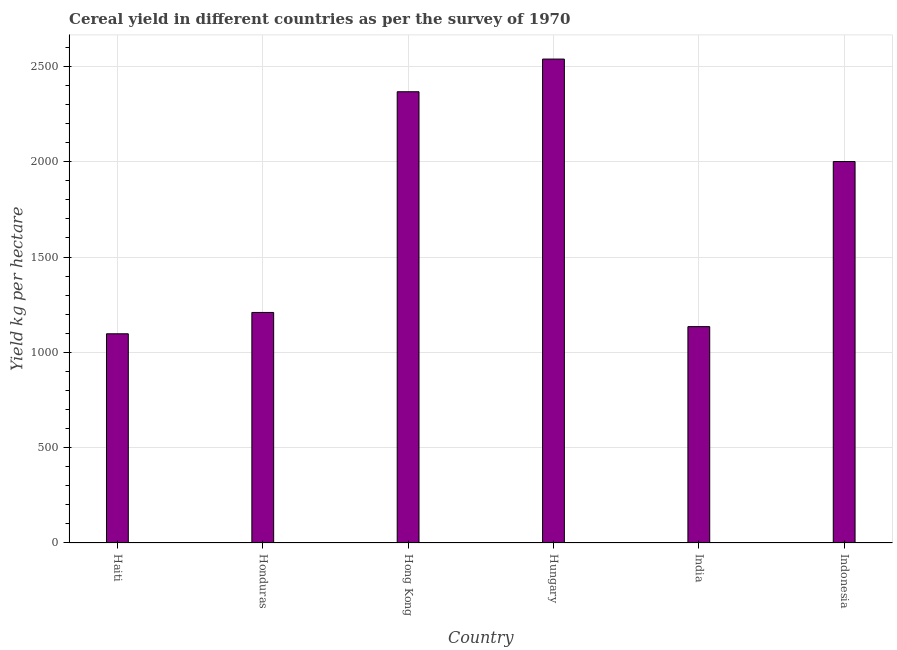Does the graph contain grids?
Give a very brief answer. Yes. What is the title of the graph?
Your response must be concise. Cereal yield in different countries as per the survey of 1970. What is the label or title of the Y-axis?
Keep it short and to the point. Yield kg per hectare. What is the cereal yield in Indonesia?
Your answer should be compact. 2000.8. Across all countries, what is the maximum cereal yield?
Give a very brief answer. 2538.25. Across all countries, what is the minimum cereal yield?
Provide a succinct answer. 1097.31. In which country was the cereal yield maximum?
Your answer should be compact. Hungary. In which country was the cereal yield minimum?
Your answer should be compact. Haiti. What is the sum of the cereal yield?
Provide a short and direct response. 1.03e+04. What is the difference between the cereal yield in Hungary and Indonesia?
Give a very brief answer. 537.45. What is the average cereal yield per country?
Ensure brevity in your answer.  1724.54. What is the median cereal yield?
Provide a short and direct response. 1605.01. In how many countries, is the cereal yield greater than 2400 kg per hectare?
Offer a very short reply. 1. What is the ratio of the cereal yield in Hong Kong to that in Hungary?
Keep it short and to the point. 0.93. Is the cereal yield in Haiti less than that in Honduras?
Provide a short and direct response. Yes. Is the difference between the cereal yield in Haiti and India greater than the difference between any two countries?
Your answer should be compact. No. What is the difference between the highest and the second highest cereal yield?
Give a very brief answer. 171.39. Is the sum of the cereal yield in Honduras and India greater than the maximum cereal yield across all countries?
Provide a succinct answer. No. What is the difference between the highest and the lowest cereal yield?
Ensure brevity in your answer.  1440.94. Are all the bars in the graph horizontal?
Offer a terse response. No. What is the difference between two consecutive major ticks on the Y-axis?
Your answer should be compact. 500. Are the values on the major ticks of Y-axis written in scientific E-notation?
Your answer should be very brief. No. What is the Yield kg per hectare in Haiti?
Your response must be concise. 1097.31. What is the Yield kg per hectare in Honduras?
Provide a succinct answer. 1209.22. What is the Yield kg per hectare of Hong Kong?
Give a very brief answer. 2366.86. What is the Yield kg per hectare in Hungary?
Your response must be concise. 2538.25. What is the Yield kg per hectare in India?
Give a very brief answer. 1134.82. What is the Yield kg per hectare of Indonesia?
Give a very brief answer. 2000.8. What is the difference between the Yield kg per hectare in Haiti and Honduras?
Give a very brief answer. -111.91. What is the difference between the Yield kg per hectare in Haiti and Hong Kong?
Your answer should be very brief. -1269.55. What is the difference between the Yield kg per hectare in Haiti and Hungary?
Give a very brief answer. -1440.94. What is the difference between the Yield kg per hectare in Haiti and India?
Give a very brief answer. -37.51. What is the difference between the Yield kg per hectare in Haiti and Indonesia?
Make the answer very short. -903.49. What is the difference between the Yield kg per hectare in Honduras and Hong Kong?
Your response must be concise. -1157.64. What is the difference between the Yield kg per hectare in Honduras and Hungary?
Your answer should be compact. -1329.03. What is the difference between the Yield kg per hectare in Honduras and India?
Keep it short and to the point. 74.4. What is the difference between the Yield kg per hectare in Honduras and Indonesia?
Ensure brevity in your answer.  -791.58. What is the difference between the Yield kg per hectare in Hong Kong and Hungary?
Your answer should be compact. -171.39. What is the difference between the Yield kg per hectare in Hong Kong and India?
Provide a succinct answer. 1232.04. What is the difference between the Yield kg per hectare in Hong Kong and Indonesia?
Your answer should be very brief. 366.06. What is the difference between the Yield kg per hectare in Hungary and India?
Keep it short and to the point. 1403.43. What is the difference between the Yield kg per hectare in Hungary and Indonesia?
Ensure brevity in your answer.  537.45. What is the difference between the Yield kg per hectare in India and Indonesia?
Ensure brevity in your answer.  -865.98. What is the ratio of the Yield kg per hectare in Haiti to that in Honduras?
Offer a terse response. 0.91. What is the ratio of the Yield kg per hectare in Haiti to that in Hong Kong?
Make the answer very short. 0.46. What is the ratio of the Yield kg per hectare in Haiti to that in Hungary?
Give a very brief answer. 0.43. What is the ratio of the Yield kg per hectare in Haiti to that in India?
Your response must be concise. 0.97. What is the ratio of the Yield kg per hectare in Haiti to that in Indonesia?
Offer a very short reply. 0.55. What is the ratio of the Yield kg per hectare in Honduras to that in Hong Kong?
Offer a terse response. 0.51. What is the ratio of the Yield kg per hectare in Honduras to that in Hungary?
Make the answer very short. 0.48. What is the ratio of the Yield kg per hectare in Honduras to that in India?
Your response must be concise. 1.07. What is the ratio of the Yield kg per hectare in Honduras to that in Indonesia?
Offer a terse response. 0.6. What is the ratio of the Yield kg per hectare in Hong Kong to that in Hungary?
Your response must be concise. 0.93. What is the ratio of the Yield kg per hectare in Hong Kong to that in India?
Offer a terse response. 2.09. What is the ratio of the Yield kg per hectare in Hong Kong to that in Indonesia?
Give a very brief answer. 1.18. What is the ratio of the Yield kg per hectare in Hungary to that in India?
Make the answer very short. 2.24. What is the ratio of the Yield kg per hectare in Hungary to that in Indonesia?
Ensure brevity in your answer.  1.27. What is the ratio of the Yield kg per hectare in India to that in Indonesia?
Ensure brevity in your answer.  0.57. 